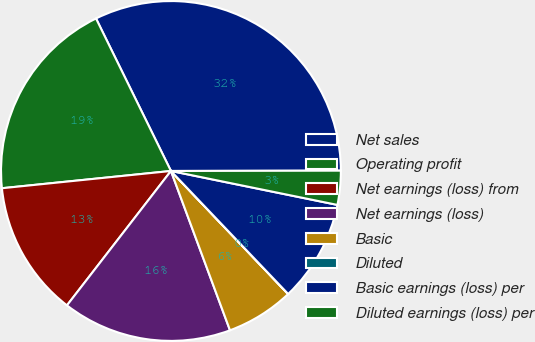<chart> <loc_0><loc_0><loc_500><loc_500><pie_chart><fcel>Net sales<fcel>Operating profit<fcel>Net earnings (loss) from<fcel>Net earnings (loss)<fcel>Basic<fcel>Diluted<fcel>Basic earnings (loss) per<fcel>Diluted earnings (loss) per<nl><fcel>32.24%<fcel>19.35%<fcel>12.9%<fcel>16.13%<fcel>6.46%<fcel>0.01%<fcel>9.68%<fcel>3.23%<nl></chart> 